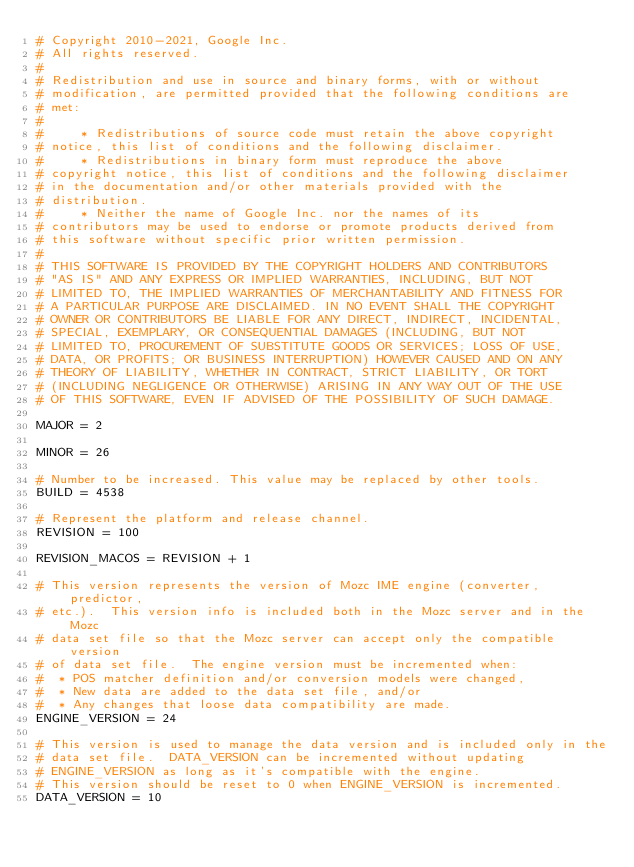<code> <loc_0><loc_0><loc_500><loc_500><_Python_># Copyright 2010-2021, Google Inc.
# All rights reserved.
#
# Redistribution and use in source and binary forms, with or without
# modification, are permitted provided that the following conditions are
# met:
#
#     * Redistributions of source code must retain the above copyright
# notice, this list of conditions and the following disclaimer.
#     * Redistributions in binary form must reproduce the above
# copyright notice, this list of conditions and the following disclaimer
# in the documentation and/or other materials provided with the
# distribution.
#     * Neither the name of Google Inc. nor the names of its
# contributors may be used to endorse or promote products derived from
# this software without specific prior written permission.
#
# THIS SOFTWARE IS PROVIDED BY THE COPYRIGHT HOLDERS AND CONTRIBUTORS
# "AS IS" AND ANY EXPRESS OR IMPLIED WARRANTIES, INCLUDING, BUT NOT
# LIMITED TO, THE IMPLIED WARRANTIES OF MERCHANTABILITY AND FITNESS FOR
# A PARTICULAR PURPOSE ARE DISCLAIMED. IN NO EVENT SHALL THE COPYRIGHT
# OWNER OR CONTRIBUTORS BE LIABLE FOR ANY DIRECT, INDIRECT, INCIDENTAL,
# SPECIAL, EXEMPLARY, OR CONSEQUENTIAL DAMAGES (INCLUDING, BUT NOT
# LIMITED TO, PROCUREMENT OF SUBSTITUTE GOODS OR SERVICES; LOSS OF USE,
# DATA, OR PROFITS; OR BUSINESS INTERRUPTION) HOWEVER CAUSED AND ON ANY
# THEORY OF LIABILITY, WHETHER IN CONTRACT, STRICT LIABILITY, OR TORT
# (INCLUDING NEGLIGENCE OR OTHERWISE) ARISING IN ANY WAY OUT OF THE USE
# OF THIS SOFTWARE, EVEN IF ADVISED OF THE POSSIBILITY OF SUCH DAMAGE.

MAJOR = 2

MINOR = 26

# Number to be increased. This value may be replaced by other tools.
BUILD = 4538

# Represent the platform and release channel.
REVISION = 100

REVISION_MACOS = REVISION + 1

# This version represents the version of Mozc IME engine (converter, predictor,
# etc.).  This version info is included both in the Mozc server and in the Mozc
# data set file so that the Mozc server can accept only the compatible version
# of data set file.  The engine version must be incremented when:
#  * POS matcher definition and/or conversion models were changed,
#  * New data are added to the data set file, and/or
#  * Any changes that loose data compatibility are made.
ENGINE_VERSION = 24

# This version is used to manage the data version and is included only in the
# data set file.  DATA_VERSION can be incremented without updating
# ENGINE_VERSION as long as it's compatible with the engine.
# This version should be reset to 0 when ENGINE_VERSION is incremented.
DATA_VERSION = 10
</code> 